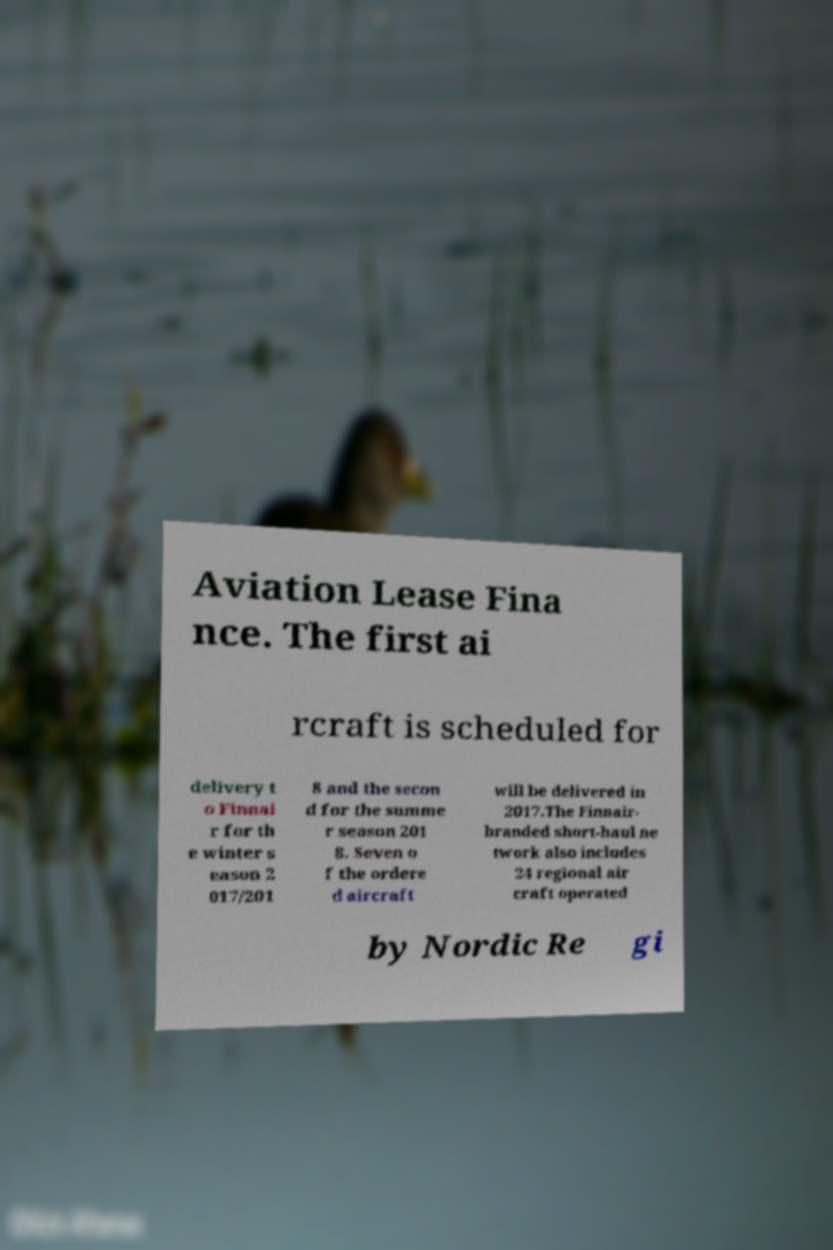What messages or text are displayed in this image? I need them in a readable, typed format. Aviation Lease Fina nce. The first ai rcraft is scheduled for delivery t o Finnai r for th e winter s eason 2 017/201 8 and the secon d for the summe r season 201 8. Seven o f the ordere d aircraft will be delivered in 2017.The Finnair- branded short-haul ne twork also includes 24 regional air craft operated by Nordic Re gi 